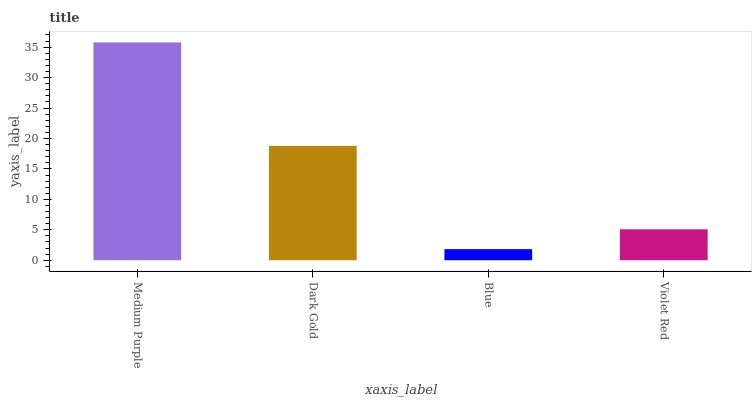Is Dark Gold the minimum?
Answer yes or no. No. Is Dark Gold the maximum?
Answer yes or no. No. Is Medium Purple greater than Dark Gold?
Answer yes or no. Yes. Is Dark Gold less than Medium Purple?
Answer yes or no. Yes. Is Dark Gold greater than Medium Purple?
Answer yes or no. No. Is Medium Purple less than Dark Gold?
Answer yes or no. No. Is Dark Gold the high median?
Answer yes or no. Yes. Is Violet Red the low median?
Answer yes or no. Yes. Is Blue the high median?
Answer yes or no. No. Is Medium Purple the low median?
Answer yes or no. No. 